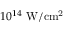Convert formula to latex. <formula><loc_0><loc_0><loc_500><loc_500>1 0 ^ { 1 4 } \ W / c m ^ { 2 }</formula> 